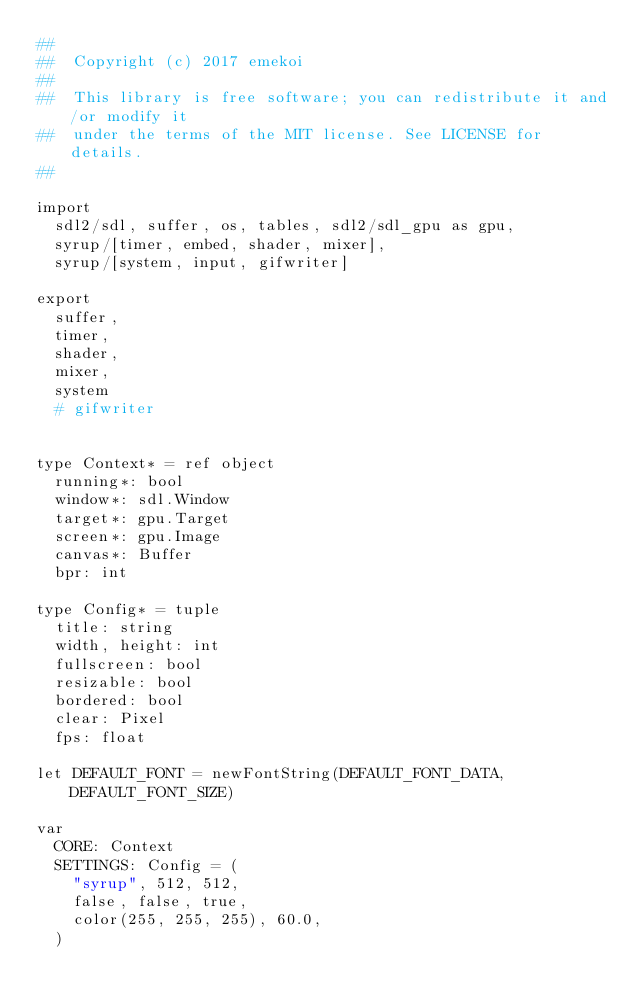Convert code to text. <code><loc_0><loc_0><loc_500><loc_500><_Nim_>##
##  Copyright (c) 2017 emekoi
##
##  This library is free software; you can redistribute it and/or modify it
##  under the terms of the MIT license. See LICENSE for details.
##

import
  sdl2/sdl, suffer, os, tables, sdl2/sdl_gpu as gpu,
  syrup/[timer, embed, shader, mixer],
  syrup/[system, input, gifwriter]

export
  suffer,
  timer,
  shader,
  mixer,
  system
  # gifwriter


type Context* = ref object
  running*: bool
  window*: sdl.Window
  target*: gpu.Target
  screen*: gpu.Image
  canvas*: Buffer
  bpr: int

type Config* = tuple
  title: string
  width, height: int
  fullscreen: bool
  resizable: bool
  bordered: bool
  clear: Pixel
  fps: float

let DEFAULT_FONT = newFontString(DEFAULT_FONT_DATA, DEFAULT_FONT_SIZE)

var
  CORE: Context
  SETTINGS: Config = (
    "syrup", 512, 512,
    false, false, true,
    color(255, 255, 255), 60.0,
  )
  </code> 